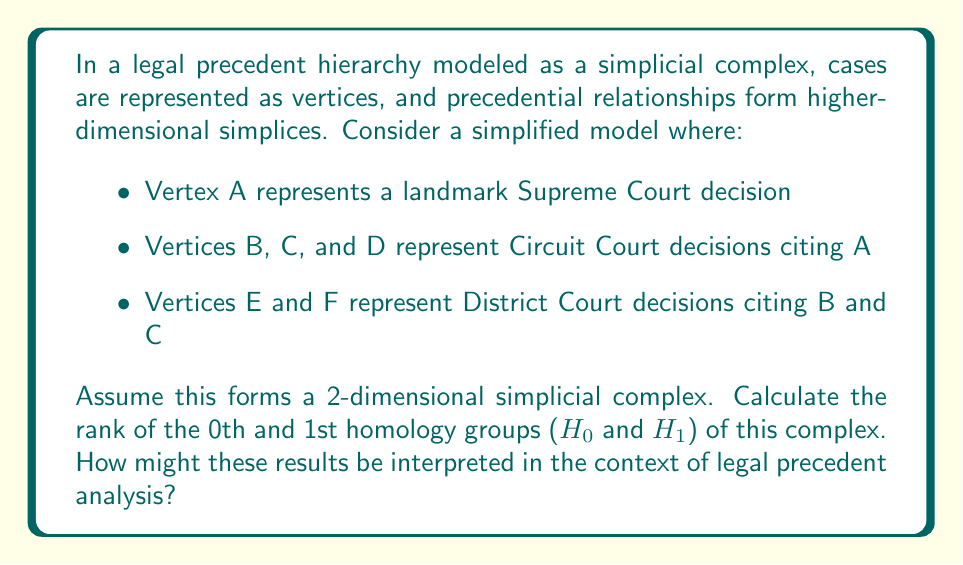Give your solution to this math problem. To solve this problem, we need to follow these steps:

1) First, let's visualize the simplicial complex:

[asy]
unitsize(1cm);
pair A=(0,2), B=(-1,0), C=(0,0), D=(1,0), E=(-1.5,-1.5), F=(0.5,-1.5);
dot("A",A,N);
dot("B",B,SW);
dot("C",C,S);
dot("D",D,SE);
dot("E",E,SW);
dot("F",F,SE);
draw(A--B--C--cycle);
draw(A--C--D--cycle);
draw(B--E);
draw(C--F);
[/asy]

2) Now, let's count the simplices:
   - 0-simplices (vertices): 6 (A, B, C, D, E, F)
   - 1-simplices (edges): 8 (AB, AC, AD, BC, CD, BE, CF, EF)
   - 2-simplices (triangles): 2 (ABC, ACD)

3) Let's calculate the Betti numbers:
   - $\beta_0$ = rank of $H_0$ = number of connected components
   - $\beta_1$ = rank of $H_1$ = number of 1-dimensional holes

4) For $\beta_0$:
   The complex is connected, so there is only one connected component.
   Therefore, $\beta_0 = 1$

5) For $\beta_1$:
   We can use the Euler characteristic formula:
   $$\chi = V - E + F = \beta_0 - \beta_1 + \beta_2$$
   Where V = number of vertices, E = number of edges, F = number of faces

   We have:
   $V = 6$, $E = 8$, $F = 2$
   $\beta_0 = 1$ (from step 4)
   $\beta_2 = 0$ (no 3D holes in a 2D complex)

   Substituting:
   $$6 - 8 + 2 = 1 - \beta_1 + 0$$
   $$0 = 1 - \beta_1$$
   $$\beta_1 = 1$$

6) Interpretation in legal context:
   - $\beta_0 = 1$ indicates a single connected body of law, suggesting all cases are related through precedential links.
   - $\beta_1 = 1$ suggests one "hole" or ambiguity in the precedent structure, possibly indicating an area where lower courts have diverged in their interpretations of the Supreme Court decision.
Answer: The ranks of the homology groups are:
$H_0: \text{rank} = 1$
$H_1: \text{rank} = 1$

These results suggest a cohesive body of law with potential for divergent interpretations in lower courts. 